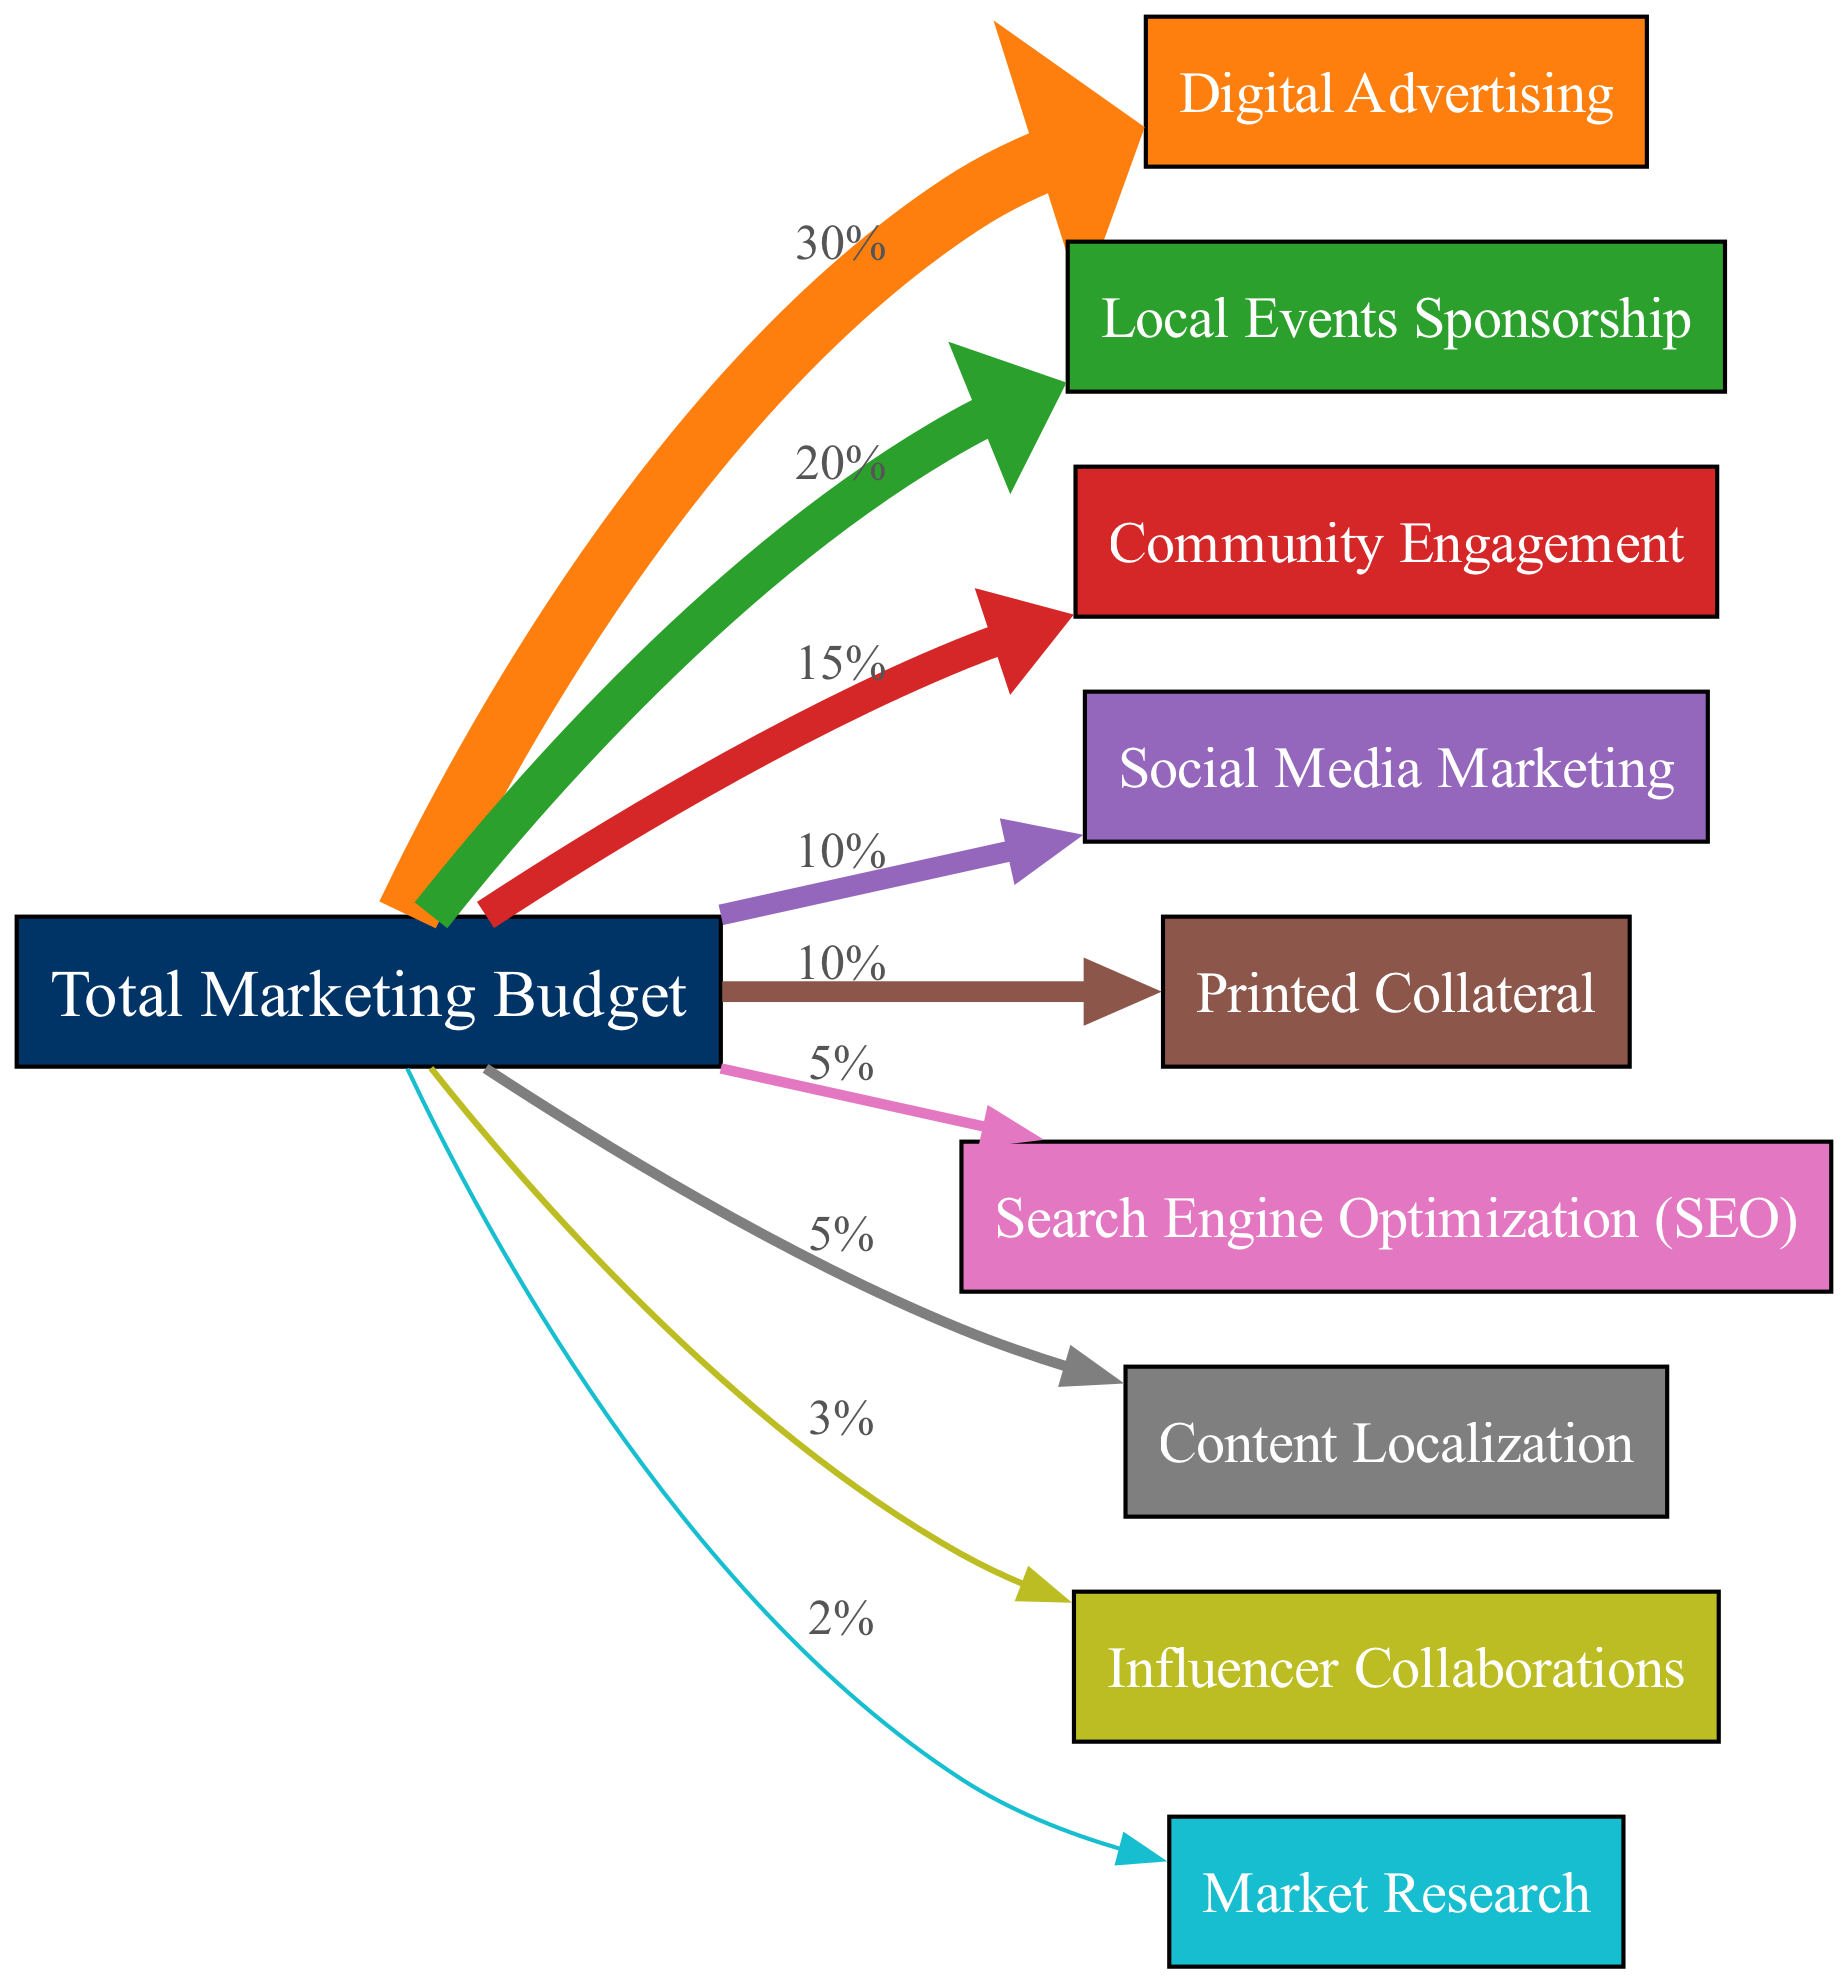What is the total percentage allocated to Digital Advertising? Locate the "Digital Advertising" node in the diagram. The value associated with this node shows how much of the total marketing budget is allocated to it. According to the data, the flow from "Total Marketing Budget" to "Digital Advertising" indicates an allocation of 30%.
Answer: 30% What percentage of the budget is allocated to Local Events Sponsorship? Find the "Local Events Sponsorship" node. The flow from "Total Marketing Budget" to this node reveals that 20% of the budget is directed towards local events.
Answer: 20% How many nodes are present in the diagram? Count all distinct nodes listed under the "nodes" section of the data. There are 10 distinct nodes shown, including "Total Marketing Budget."
Answer: 10 Which has a higher allocation: Community Engagement or Influencer Collaborations? Compare the values at the "Community Engagement" and "Influencer Collaborations" nodes. Community Engagement has a budget allocation of 15%, while Influencer Collaborations is allocated 3%. Therefore, Community Engagement has a higher allocation.
Answer: Community Engagement What is the total percentage allocated to printed collateral and market research combined? First, find the allocations for both nodes: "Printed Collateral" shows 10%, and "Market Research" shows 2%. Summing these values gives 12%.
Answer: 12% Which marketing strategy received the smallest allocation? Look at the flow values for all marketing strategies. Comparing them reveals "Market Research" with the lowest allocation at 2%.
Answer: Market Research How does the percentage allocated to Social Media Marketing compare to that allocated to Search Engine Optimization (SEO)? Evaluate the values for both nodes: "Social Media Marketing" is allocated 10%, while "Search Engine Optimization (SEO)" is allocated 5%. Since 10% is greater than 5%, Social Media Marketing received a higher allocation.
Answer: Social Media Marketing What percentage of the total marketing budget is allocated to Content Localization? Locate the "Content Localization" node in the diagram, where the direct allocation from "Total Marketing Budget" is shown as 5%. Therefore, this is the percentage allocated.
Answer: 5% Which strategy has the highest budget allocation apart from Digital Advertising? Examine the remaining allocations after Digital Advertising. The highest allocation after that is for "Local Events Sponsorship" at 20%, making it the next highest.
Answer: Local Events Sponsorship 